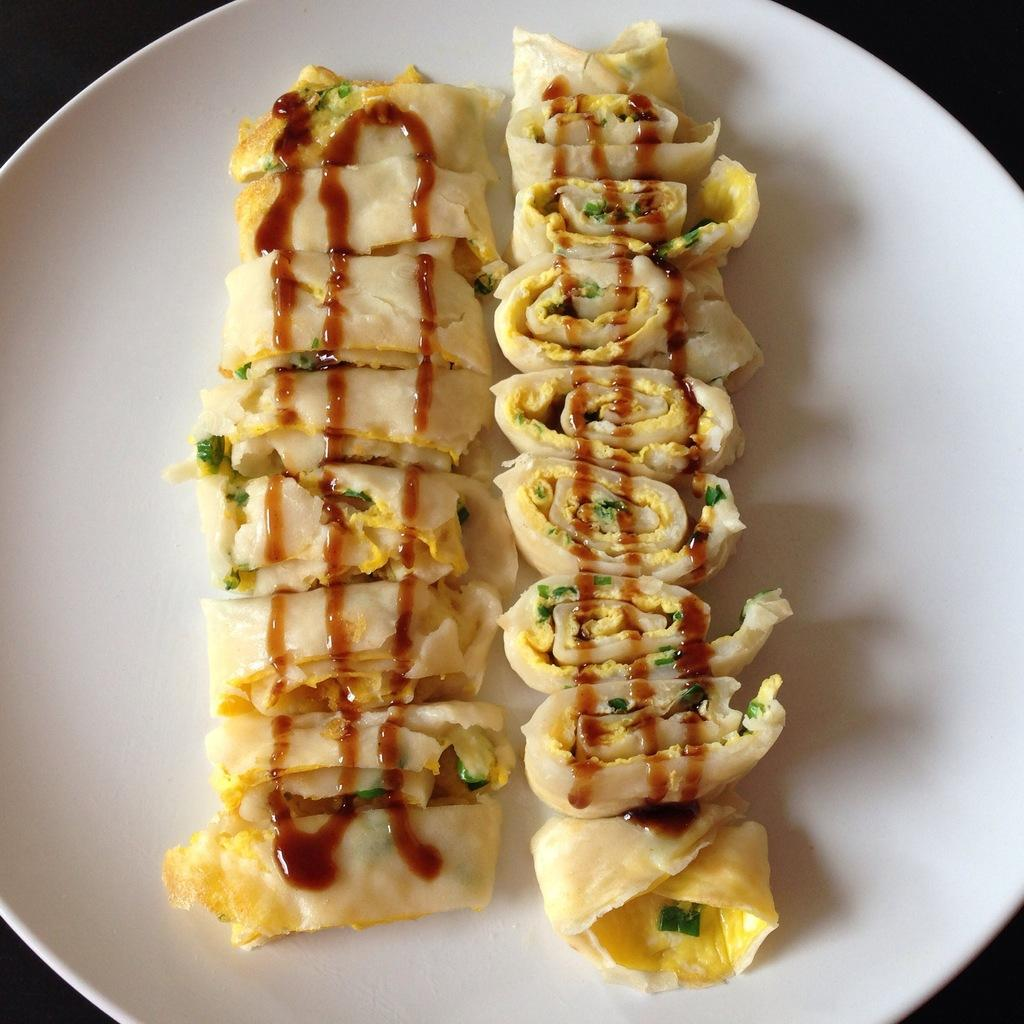What is on the plate that is visible in the image? Food items are present on the plate. Where might this image have been taken? The image may have been taken in a room. What type of fire can be seen in the image? There is no fire present in the image. How many lights are visible in the image? The number of lights cannot be determined from the provided facts, as the image may have been taken in a room with various lighting conditions. 